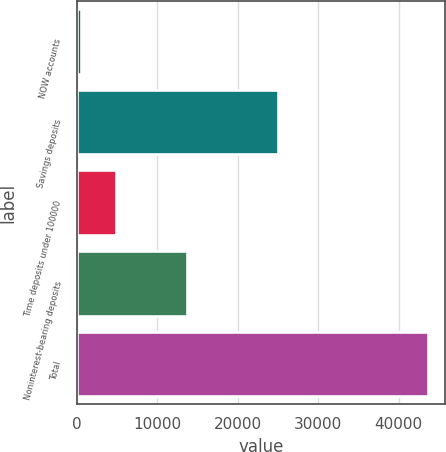Convert chart. <chart><loc_0><loc_0><loc_500><loc_500><bar_chart><fcel>NOW accounts<fcel>Savings deposits<fcel>Time deposits under 100000<fcel>Noninterest-bearing deposits<fcel>Total<nl><fcel>581<fcel>25027<fcel>4882.4<fcel>13709<fcel>43595<nl></chart> 